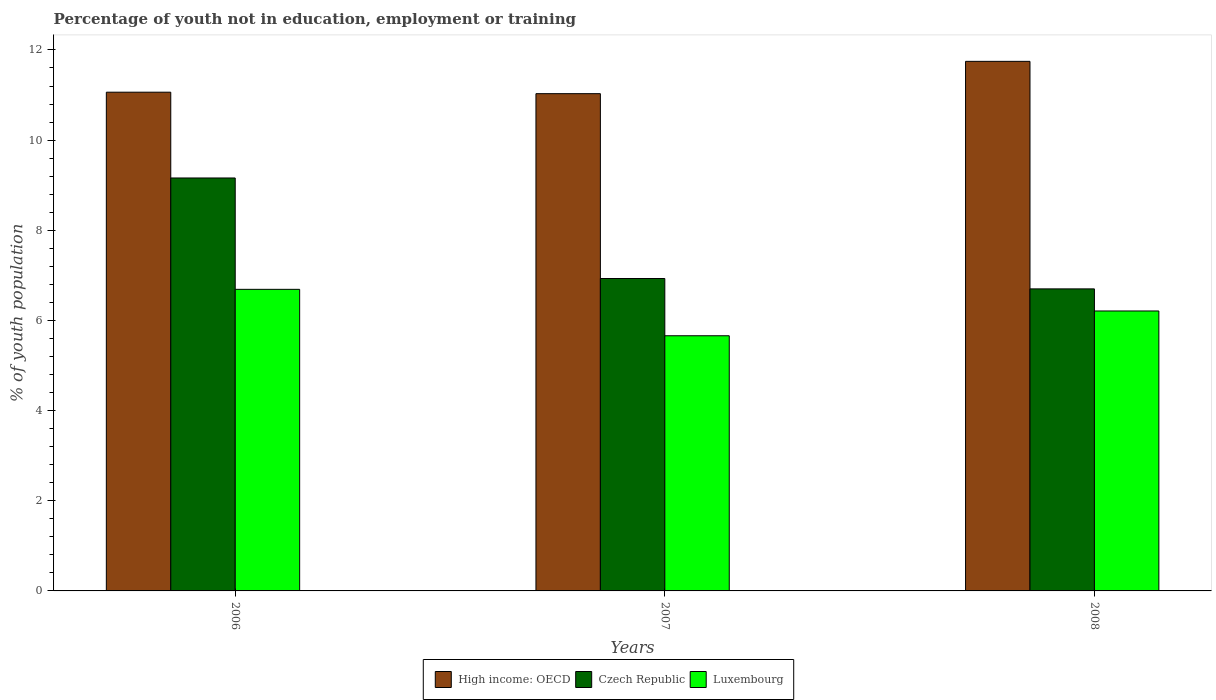How many different coloured bars are there?
Ensure brevity in your answer.  3. Are the number of bars per tick equal to the number of legend labels?
Provide a short and direct response. Yes. How many bars are there on the 2nd tick from the left?
Provide a short and direct response. 3. How many bars are there on the 1st tick from the right?
Give a very brief answer. 3. In how many cases, is the number of bars for a given year not equal to the number of legend labels?
Keep it short and to the point. 0. What is the percentage of unemployed youth population in in Czech Republic in 2008?
Your response must be concise. 6.7. Across all years, what is the maximum percentage of unemployed youth population in in High income: OECD?
Keep it short and to the point. 11.75. Across all years, what is the minimum percentage of unemployed youth population in in Czech Republic?
Your response must be concise. 6.7. In which year was the percentage of unemployed youth population in in Luxembourg maximum?
Your response must be concise. 2006. In which year was the percentage of unemployed youth population in in High income: OECD minimum?
Your answer should be compact. 2007. What is the total percentage of unemployed youth population in in High income: OECD in the graph?
Your response must be concise. 33.84. What is the difference between the percentage of unemployed youth population in in Czech Republic in 2006 and that in 2008?
Ensure brevity in your answer.  2.46. What is the difference between the percentage of unemployed youth population in in Luxembourg in 2007 and the percentage of unemployed youth population in in Czech Republic in 2006?
Provide a succinct answer. -3.5. What is the average percentage of unemployed youth population in in Czech Republic per year?
Your answer should be compact. 7.6. In the year 2008, what is the difference between the percentage of unemployed youth population in in Luxembourg and percentage of unemployed youth population in in High income: OECD?
Your answer should be compact. -5.54. What is the ratio of the percentage of unemployed youth population in in Czech Republic in 2006 to that in 2008?
Make the answer very short. 1.37. Is the percentage of unemployed youth population in in Czech Republic in 2006 less than that in 2008?
Provide a succinct answer. No. Is the difference between the percentage of unemployed youth population in in Luxembourg in 2006 and 2008 greater than the difference between the percentage of unemployed youth population in in High income: OECD in 2006 and 2008?
Provide a short and direct response. Yes. What is the difference between the highest and the second highest percentage of unemployed youth population in in Luxembourg?
Provide a short and direct response. 0.48. What is the difference between the highest and the lowest percentage of unemployed youth population in in High income: OECD?
Provide a succinct answer. 0.72. Is the sum of the percentage of unemployed youth population in in Luxembourg in 2006 and 2007 greater than the maximum percentage of unemployed youth population in in High income: OECD across all years?
Make the answer very short. Yes. What does the 2nd bar from the left in 2007 represents?
Give a very brief answer. Czech Republic. What does the 1st bar from the right in 2008 represents?
Your response must be concise. Luxembourg. Is it the case that in every year, the sum of the percentage of unemployed youth population in in High income: OECD and percentage of unemployed youth population in in Czech Republic is greater than the percentage of unemployed youth population in in Luxembourg?
Your answer should be compact. Yes. How many bars are there?
Provide a succinct answer. 9. How many years are there in the graph?
Make the answer very short. 3. Are the values on the major ticks of Y-axis written in scientific E-notation?
Make the answer very short. No. Does the graph contain grids?
Your answer should be compact. No. How many legend labels are there?
Provide a short and direct response. 3. How are the legend labels stacked?
Keep it short and to the point. Horizontal. What is the title of the graph?
Provide a short and direct response. Percentage of youth not in education, employment or training. Does "Hong Kong" appear as one of the legend labels in the graph?
Give a very brief answer. No. What is the label or title of the X-axis?
Your answer should be compact. Years. What is the label or title of the Y-axis?
Give a very brief answer. % of youth population. What is the % of youth population in High income: OECD in 2006?
Ensure brevity in your answer.  11.06. What is the % of youth population of Czech Republic in 2006?
Ensure brevity in your answer.  9.16. What is the % of youth population of Luxembourg in 2006?
Give a very brief answer. 6.69. What is the % of youth population in High income: OECD in 2007?
Ensure brevity in your answer.  11.03. What is the % of youth population of Czech Republic in 2007?
Offer a terse response. 6.93. What is the % of youth population of Luxembourg in 2007?
Provide a succinct answer. 5.66. What is the % of youth population of High income: OECD in 2008?
Provide a short and direct response. 11.75. What is the % of youth population of Czech Republic in 2008?
Provide a short and direct response. 6.7. What is the % of youth population in Luxembourg in 2008?
Your response must be concise. 6.21. Across all years, what is the maximum % of youth population of High income: OECD?
Offer a very short reply. 11.75. Across all years, what is the maximum % of youth population in Czech Republic?
Provide a succinct answer. 9.16. Across all years, what is the maximum % of youth population of Luxembourg?
Offer a terse response. 6.69. Across all years, what is the minimum % of youth population in High income: OECD?
Your answer should be very brief. 11.03. Across all years, what is the minimum % of youth population in Czech Republic?
Your answer should be compact. 6.7. Across all years, what is the minimum % of youth population in Luxembourg?
Provide a succinct answer. 5.66. What is the total % of youth population of High income: OECD in the graph?
Keep it short and to the point. 33.84. What is the total % of youth population of Czech Republic in the graph?
Provide a succinct answer. 22.79. What is the total % of youth population in Luxembourg in the graph?
Your response must be concise. 18.56. What is the difference between the % of youth population in High income: OECD in 2006 and that in 2007?
Give a very brief answer. 0.03. What is the difference between the % of youth population of Czech Republic in 2006 and that in 2007?
Your answer should be compact. 2.23. What is the difference between the % of youth population in Luxembourg in 2006 and that in 2007?
Provide a succinct answer. 1.03. What is the difference between the % of youth population of High income: OECD in 2006 and that in 2008?
Provide a succinct answer. -0.68. What is the difference between the % of youth population in Czech Republic in 2006 and that in 2008?
Keep it short and to the point. 2.46. What is the difference between the % of youth population in Luxembourg in 2006 and that in 2008?
Make the answer very short. 0.48. What is the difference between the % of youth population of High income: OECD in 2007 and that in 2008?
Offer a very short reply. -0.72. What is the difference between the % of youth population in Czech Republic in 2007 and that in 2008?
Your answer should be very brief. 0.23. What is the difference between the % of youth population of Luxembourg in 2007 and that in 2008?
Offer a terse response. -0.55. What is the difference between the % of youth population of High income: OECD in 2006 and the % of youth population of Czech Republic in 2007?
Your answer should be compact. 4.13. What is the difference between the % of youth population of High income: OECD in 2006 and the % of youth population of Luxembourg in 2007?
Provide a succinct answer. 5.4. What is the difference between the % of youth population in High income: OECD in 2006 and the % of youth population in Czech Republic in 2008?
Keep it short and to the point. 4.36. What is the difference between the % of youth population in High income: OECD in 2006 and the % of youth population in Luxembourg in 2008?
Your answer should be compact. 4.85. What is the difference between the % of youth population in Czech Republic in 2006 and the % of youth population in Luxembourg in 2008?
Provide a succinct answer. 2.95. What is the difference between the % of youth population of High income: OECD in 2007 and the % of youth population of Czech Republic in 2008?
Offer a very short reply. 4.33. What is the difference between the % of youth population in High income: OECD in 2007 and the % of youth population in Luxembourg in 2008?
Keep it short and to the point. 4.82. What is the difference between the % of youth population in Czech Republic in 2007 and the % of youth population in Luxembourg in 2008?
Offer a terse response. 0.72. What is the average % of youth population in High income: OECD per year?
Your response must be concise. 11.28. What is the average % of youth population in Czech Republic per year?
Make the answer very short. 7.6. What is the average % of youth population in Luxembourg per year?
Ensure brevity in your answer.  6.19. In the year 2006, what is the difference between the % of youth population in High income: OECD and % of youth population in Czech Republic?
Give a very brief answer. 1.9. In the year 2006, what is the difference between the % of youth population of High income: OECD and % of youth population of Luxembourg?
Your response must be concise. 4.37. In the year 2006, what is the difference between the % of youth population of Czech Republic and % of youth population of Luxembourg?
Provide a succinct answer. 2.47. In the year 2007, what is the difference between the % of youth population of High income: OECD and % of youth population of Czech Republic?
Your response must be concise. 4.1. In the year 2007, what is the difference between the % of youth population in High income: OECD and % of youth population in Luxembourg?
Your response must be concise. 5.37. In the year 2007, what is the difference between the % of youth population of Czech Republic and % of youth population of Luxembourg?
Ensure brevity in your answer.  1.27. In the year 2008, what is the difference between the % of youth population in High income: OECD and % of youth population in Czech Republic?
Offer a terse response. 5.05. In the year 2008, what is the difference between the % of youth population in High income: OECD and % of youth population in Luxembourg?
Your response must be concise. 5.54. In the year 2008, what is the difference between the % of youth population of Czech Republic and % of youth population of Luxembourg?
Keep it short and to the point. 0.49. What is the ratio of the % of youth population in Czech Republic in 2006 to that in 2007?
Your answer should be compact. 1.32. What is the ratio of the % of youth population in Luxembourg in 2006 to that in 2007?
Provide a short and direct response. 1.18. What is the ratio of the % of youth population of High income: OECD in 2006 to that in 2008?
Give a very brief answer. 0.94. What is the ratio of the % of youth population of Czech Republic in 2006 to that in 2008?
Provide a short and direct response. 1.37. What is the ratio of the % of youth population of Luxembourg in 2006 to that in 2008?
Keep it short and to the point. 1.08. What is the ratio of the % of youth population of High income: OECD in 2007 to that in 2008?
Make the answer very short. 0.94. What is the ratio of the % of youth population of Czech Republic in 2007 to that in 2008?
Your answer should be compact. 1.03. What is the ratio of the % of youth population in Luxembourg in 2007 to that in 2008?
Ensure brevity in your answer.  0.91. What is the difference between the highest and the second highest % of youth population in High income: OECD?
Provide a succinct answer. 0.68. What is the difference between the highest and the second highest % of youth population in Czech Republic?
Make the answer very short. 2.23. What is the difference between the highest and the second highest % of youth population of Luxembourg?
Offer a terse response. 0.48. What is the difference between the highest and the lowest % of youth population in High income: OECD?
Offer a very short reply. 0.72. What is the difference between the highest and the lowest % of youth population of Czech Republic?
Provide a succinct answer. 2.46. What is the difference between the highest and the lowest % of youth population in Luxembourg?
Your answer should be compact. 1.03. 